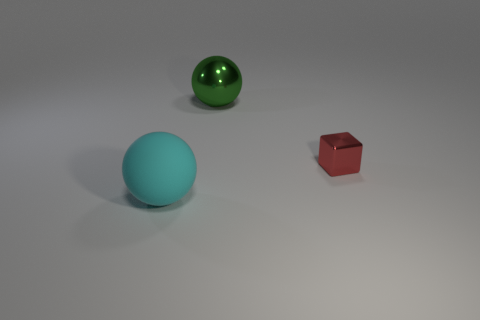There is another green object that is the same shape as the matte thing; what is its size?
Your answer should be very brief. Large. Are there more balls in front of the small red shiny object than big yellow rubber balls?
Give a very brief answer. Yes. Is the material of the red thing the same as the cyan sphere?
Ensure brevity in your answer.  No. How many objects are big spheres behind the rubber ball or big balls that are in front of the tiny cube?
Give a very brief answer. 2. The big matte thing that is the same shape as the large metal object is what color?
Your answer should be very brief. Cyan. What number of things are either metallic things behind the cube or large gray metallic blocks?
Keep it short and to the point. 1. The metal object in front of the metallic ball that is on the right side of the large ball in front of the tiny red block is what color?
Your answer should be very brief. Red. There is a large object that is the same material as the block; what is its color?
Keep it short and to the point. Green. What number of green cylinders are the same material as the tiny cube?
Keep it short and to the point. 0. There is a ball left of the green sphere; is it the same size as the large green object?
Ensure brevity in your answer.  Yes. 